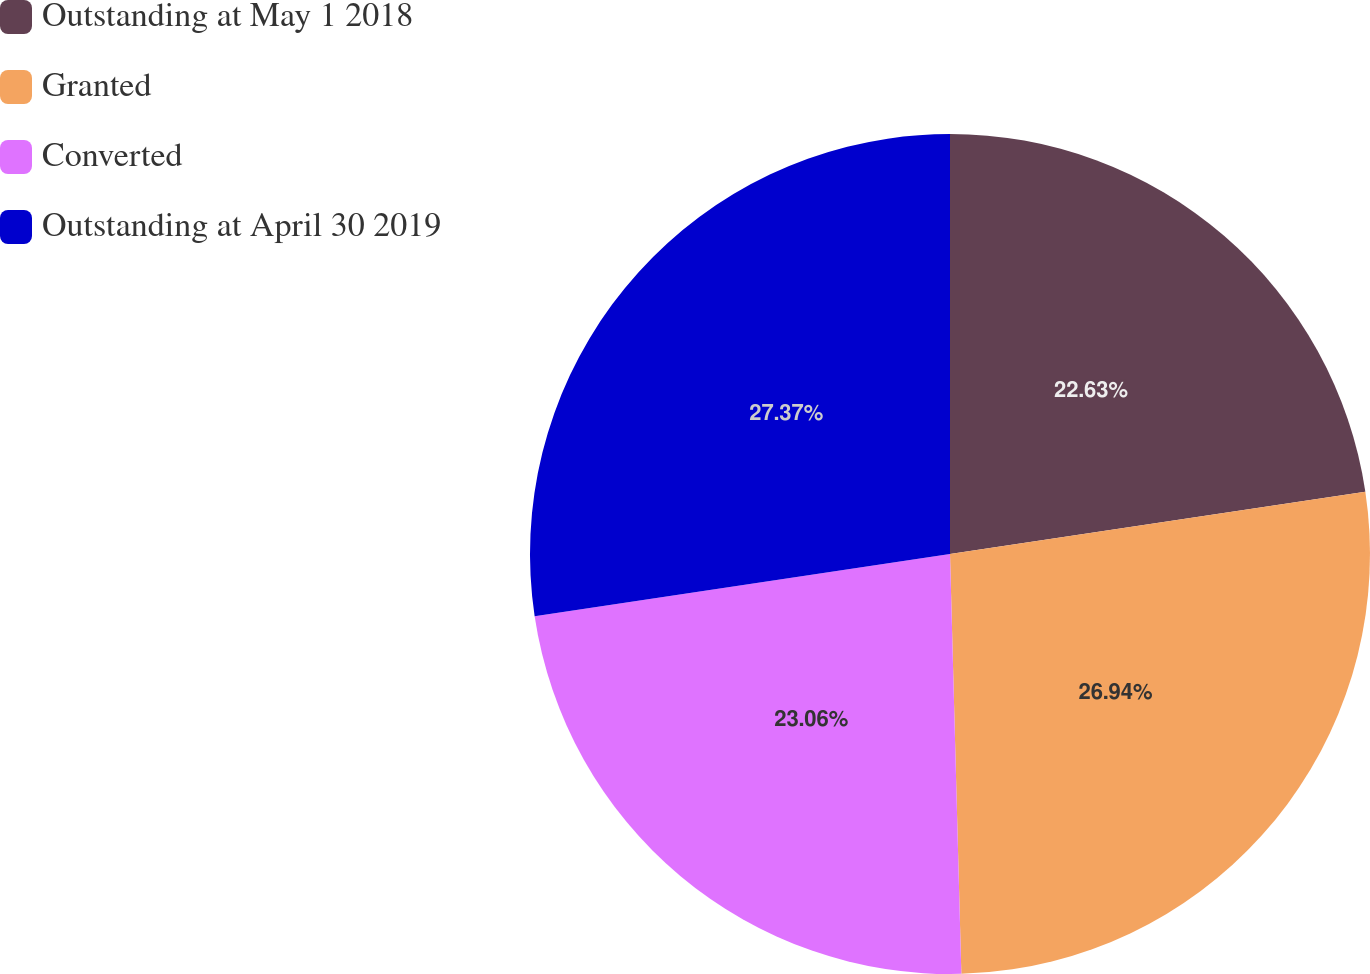Convert chart. <chart><loc_0><loc_0><loc_500><loc_500><pie_chart><fcel>Outstanding at May 1 2018<fcel>Granted<fcel>Converted<fcel>Outstanding at April 30 2019<nl><fcel>22.63%<fcel>26.94%<fcel>23.06%<fcel>27.37%<nl></chart> 